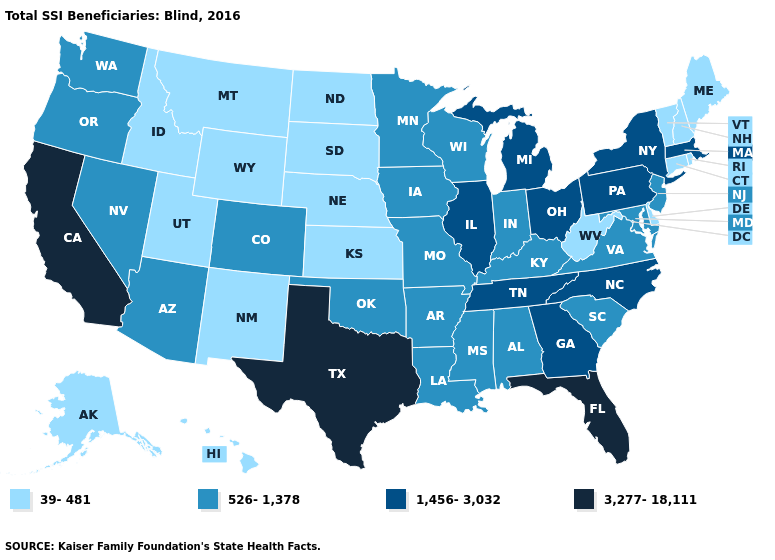Does Maine have the highest value in the Northeast?
Keep it brief. No. Name the states that have a value in the range 3,277-18,111?
Keep it brief. California, Florida, Texas. What is the value of North Dakota?
Quick response, please. 39-481. What is the value of New York?
Short answer required. 1,456-3,032. What is the highest value in states that border Massachusetts?
Keep it brief. 1,456-3,032. Does Indiana have the highest value in the MidWest?
Answer briefly. No. What is the highest value in the USA?
Write a very short answer. 3,277-18,111. Among the states that border New Jersey , which have the lowest value?
Quick response, please. Delaware. What is the highest value in the USA?
Concise answer only. 3,277-18,111. Does Washington have the highest value in the West?
Quick response, please. No. What is the highest value in states that border California?
Be succinct. 526-1,378. Name the states that have a value in the range 3,277-18,111?
Short answer required. California, Florida, Texas. Which states hav the highest value in the Northeast?
Quick response, please. Massachusetts, New York, Pennsylvania. What is the value of Ohio?
Keep it brief. 1,456-3,032. How many symbols are there in the legend?
Answer briefly. 4. 